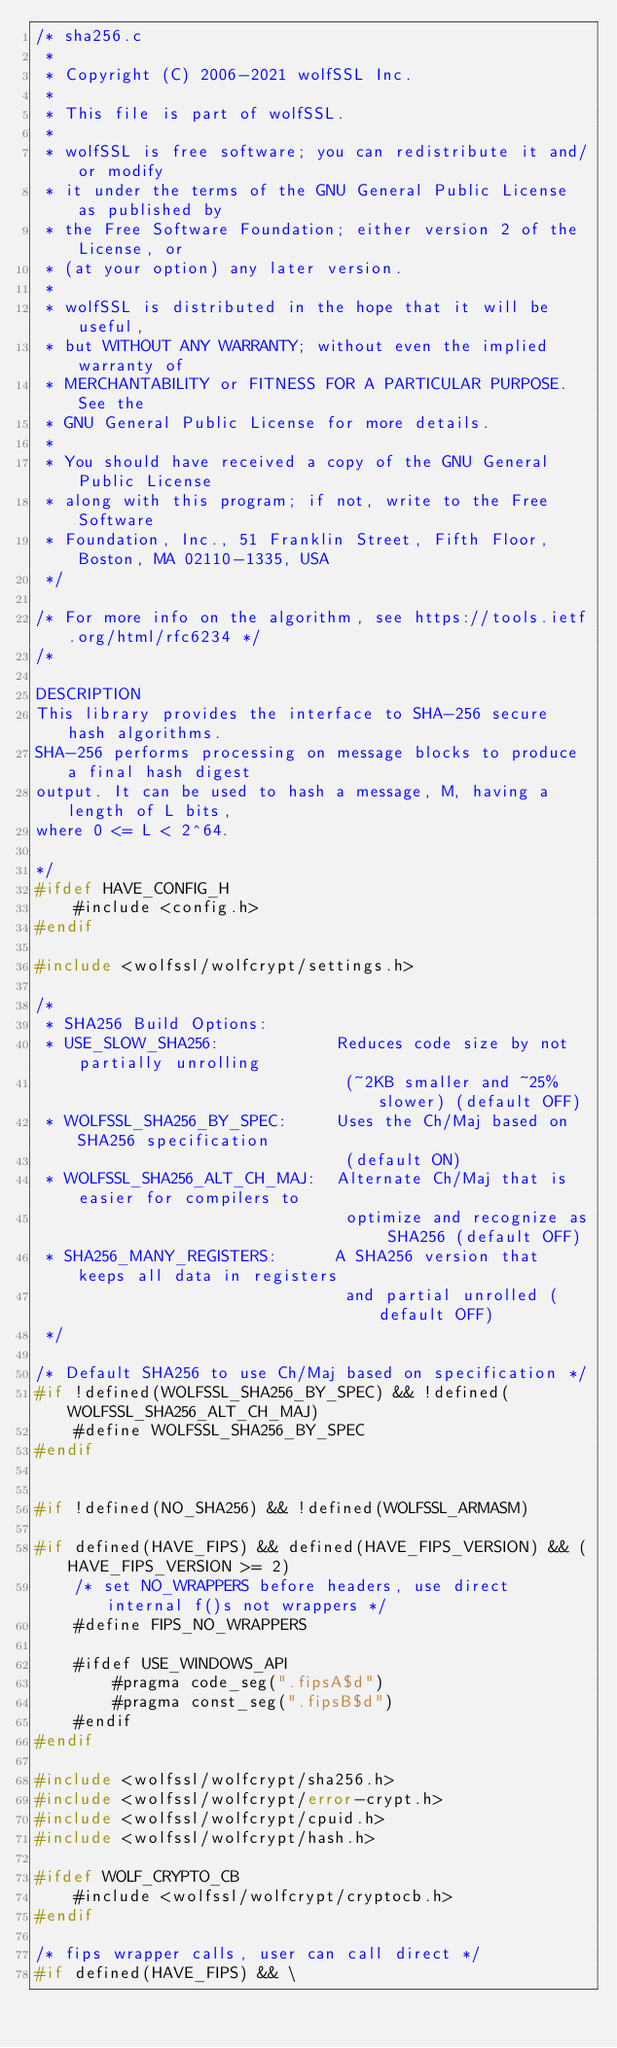Convert code to text. <code><loc_0><loc_0><loc_500><loc_500><_C_>/* sha256.c
 *
 * Copyright (C) 2006-2021 wolfSSL Inc.
 *
 * This file is part of wolfSSL.
 *
 * wolfSSL is free software; you can redistribute it and/or modify
 * it under the terms of the GNU General Public License as published by
 * the Free Software Foundation; either version 2 of the License, or
 * (at your option) any later version.
 *
 * wolfSSL is distributed in the hope that it will be useful,
 * but WITHOUT ANY WARRANTY; without even the implied warranty of
 * MERCHANTABILITY or FITNESS FOR A PARTICULAR PURPOSE.  See the
 * GNU General Public License for more details.
 *
 * You should have received a copy of the GNU General Public License
 * along with this program; if not, write to the Free Software
 * Foundation, Inc., 51 Franklin Street, Fifth Floor, Boston, MA 02110-1335, USA
 */

/* For more info on the algorithm, see https://tools.ietf.org/html/rfc6234 */
/*

DESCRIPTION
This library provides the interface to SHA-256 secure hash algorithms.
SHA-256 performs processing on message blocks to produce a final hash digest
output. It can be used to hash a message, M, having a length of L bits,
where 0 <= L < 2^64.

*/
#ifdef HAVE_CONFIG_H
    #include <config.h>
#endif

#include <wolfssl/wolfcrypt/settings.h>

/*
 * SHA256 Build Options:
 * USE_SLOW_SHA256:            Reduces code size by not partially unrolling
                                (~2KB smaller and ~25% slower) (default OFF)
 * WOLFSSL_SHA256_BY_SPEC:     Uses the Ch/Maj based on SHA256 specification
                                (default ON)
 * WOLFSSL_SHA256_ALT_CH_MAJ:  Alternate Ch/Maj that is easier for compilers to
                                optimize and recognize as SHA256 (default OFF)
 * SHA256_MANY_REGISTERS:      A SHA256 version that keeps all data in registers
                                and partial unrolled (default OFF)
 */

/* Default SHA256 to use Ch/Maj based on specification */
#if !defined(WOLFSSL_SHA256_BY_SPEC) && !defined(WOLFSSL_SHA256_ALT_CH_MAJ)
    #define WOLFSSL_SHA256_BY_SPEC
#endif


#if !defined(NO_SHA256) && !defined(WOLFSSL_ARMASM)

#if defined(HAVE_FIPS) && defined(HAVE_FIPS_VERSION) && (HAVE_FIPS_VERSION >= 2)
    /* set NO_WRAPPERS before headers, use direct internal f()s not wrappers */
    #define FIPS_NO_WRAPPERS

    #ifdef USE_WINDOWS_API
        #pragma code_seg(".fipsA$d")
        #pragma const_seg(".fipsB$d")
    #endif
#endif

#include <wolfssl/wolfcrypt/sha256.h>
#include <wolfssl/wolfcrypt/error-crypt.h>
#include <wolfssl/wolfcrypt/cpuid.h>
#include <wolfssl/wolfcrypt/hash.h>

#ifdef WOLF_CRYPTO_CB
    #include <wolfssl/wolfcrypt/cryptocb.h>
#endif

/* fips wrapper calls, user can call direct */
#if defined(HAVE_FIPS) && \</code> 